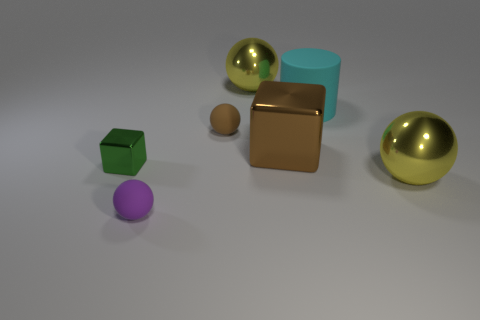What shape is the tiny purple object that is the same material as the cyan object?
Your response must be concise. Sphere. Is the number of big rubber things that are to the left of the brown metal block less than the number of brown spheres?
Ensure brevity in your answer.  Yes. Does the large brown metal object have the same shape as the small green thing?
Make the answer very short. Yes. How many metallic things are tiny green blocks or blue cubes?
Make the answer very short. 1. Are there any red rubber things of the same size as the matte cylinder?
Make the answer very short. No. The tiny rubber object that is the same color as the large metallic block is what shape?
Offer a very short reply. Sphere. How many green things have the same size as the green metallic cube?
Your answer should be compact. 0. There is a cube on the left side of the brown ball; does it have the same size as the yellow shiny object in front of the tiny shiny cube?
Give a very brief answer. No. What number of objects are either tiny brown things or large spheres in front of the matte cylinder?
Offer a very short reply. 2. What is the color of the big cylinder?
Offer a very short reply. Cyan. 